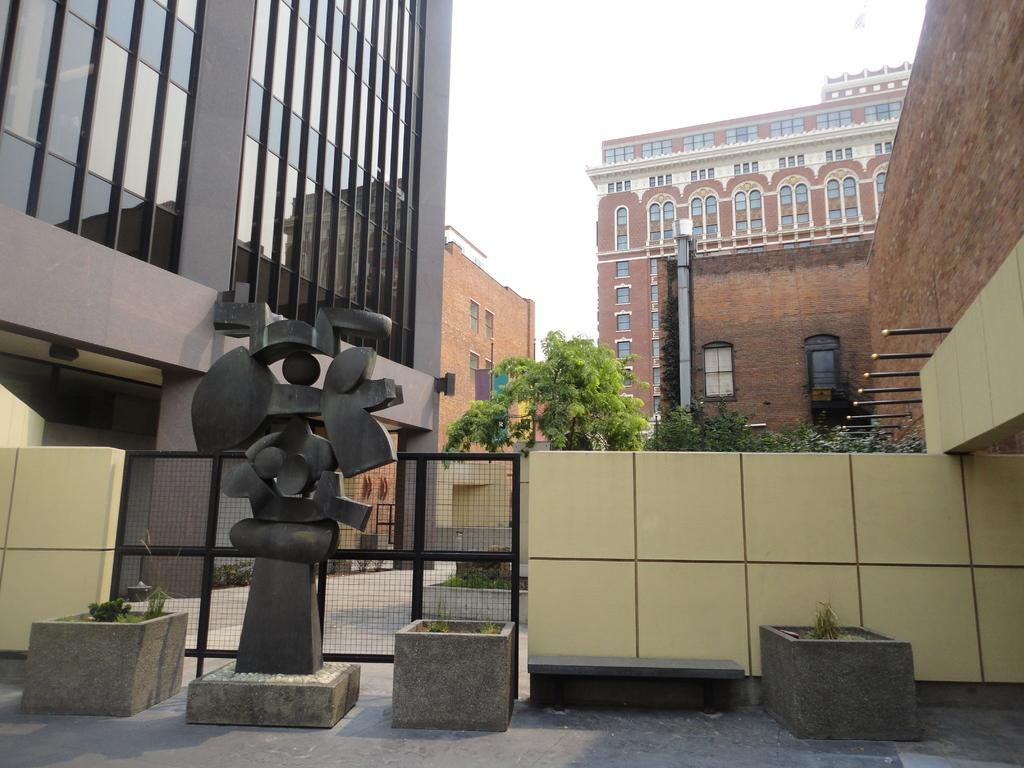What type of structures can be seen in the image? There are buildings in the image. What type of vegetation is present in the image? There are trees and plants in the image. What architectural feature can be seen in the image? There is a fence in the image. What type of artwork is present in the image? There is a statue in the image. What is visible in the background of the image? The sky is visible in the background of the image. What is the income of the kittens in the image? There are no kittens present in the image, so their income cannot be determined. 